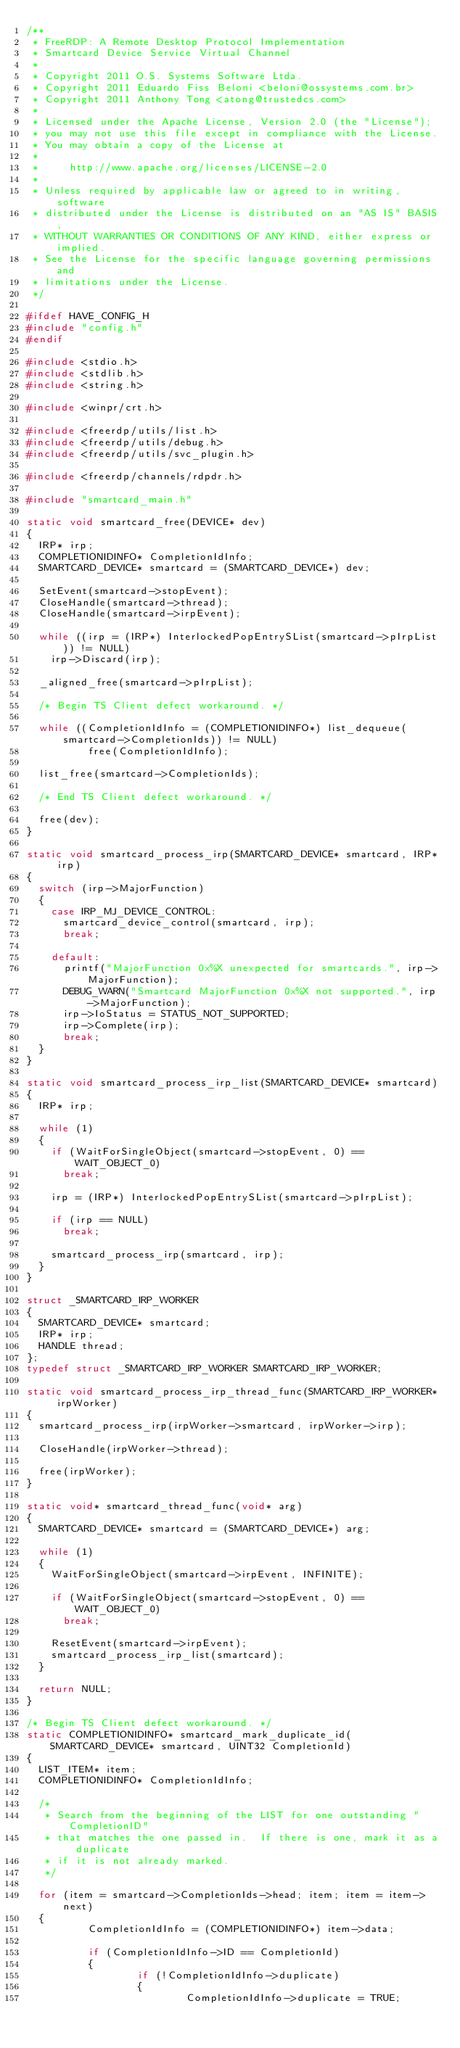<code> <loc_0><loc_0><loc_500><loc_500><_C_>/**
 * FreeRDP: A Remote Desktop Protocol Implementation
 * Smartcard Device Service Virtual Channel
 *
 * Copyright 2011 O.S. Systems Software Ltda.
 * Copyright 2011 Eduardo Fiss Beloni <beloni@ossystems.com.br>
 * Copyright 2011 Anthony Tong <atong@trustedcs.com>
 *
 * Licensed under the Apache License, Version 2.0 (the "License");
 * you may not use this file except in compliance with the License.
 * You may obtain a copy of the License at
 *
 *     http://www.apache.org/licenses/LICENSE-2.0
 *
 * Unless required by applicable law or agreed to in writing, software
 * distributed under the License is distributed on an "AS IS" BASIS,
 * WITHOUT WARRANTIES OR CONDITIONS OF ANY KIND, either express or implied.
 * See the License for the specific language governing permissions and
 * limitations under the License.
 */

#ifdef HAVE_CONFIG_H
#include "config.h"
#endif

#include <stdio.h>
#include <stdlib.h>
#include <string.h>

#include <winpr/crt.h>

#include <freerdp/utils/list.h>
#include <freerdp/utils/debug.h>
#include <freerdp/utils/svc_plugin.h>

#include <freerdp/channels/rdpdr.h>

#include "smartcard_main.h"

static void smartcard_free(DEVICE* dev)
{
	IRP* irp;
	COMPLETIONIDINFO* CompletionIdInfo;
	SMARTCARD_DEVICE* smartcard = (SMARTCARD_DEVICE*) dev;

	SetEvent(smartcard->stopEvent);
	CloseHandle(smartcard->thread);
	CloseHandle(smartcard->irpEvent);

	while ((irp = (IRP*) InterlockedPopEntrySList(smartcard->pIrpList)) != NULL)
		irp->Discard(irp);

	_aligned_free(smartcard->pIrpList);

	/* Begin TS Client defect workaround. */

	while ((CompletionIdInfo = (COMPLETIONIDINFO*) list_dequeue(smartcard->CompletionIds)) != NULL)
	        free(CompletionIdInfo);

	list_free(smartcard->CompletionIds);

	/* End TS Client defect workaround. */

	free(dev);
}

static void smartcard_process_irp(SMARTCARD_DEVICE* smartcard, IRP* irp)
{
	switch (irp->MajorFunction)
	{
		case IRP_MJ_DEVICE_CONTROL:
			smartcard_device_control(smartcard, irp);
			break;

		default:
			printf("MajorFunction 0x%X unexpected for smartcards.", irp->MajorFunction);
			DEBUG_WARN("Smartcard MajorFunction 0x%X not supported.", irp->MajorFunction);
			irp->IoStatus = STATUS_NOT_SUPPORTED;
			irp->Complete(irp);
			break;
	}
}

static void smartcard_process_irp_list(SMARTCARD_DEVICE* smartcard)
{
	IRP* irp;

	while (1)
	{
		if (WaitForSingleObject(smartcard->stopEvent, 0) == WAIT_OBJECT_0)
			break;

		irp = (IRP*) InterlockedPopEntrySList(smartcard->pIrpList);

		if (irp == NULL)
			break;

		smartcard_process_irp(smartcard, irp);
	}
}

struct _SMARTCARD_IRP_WORKER
{
	SMARTCARD_DEVICE* smartcard;
	IRP* irp;
	HANDLE thread;
};
typedef struct _SMARTCARD_IRP_WORKER SMARTCARD_IRP_WORKER;
 
static void smartcard_process_irp_thread_func(SMARTCARD_IRP_WORKER* irpWorker)
{
	smartcard_process_irp(irpWorker->smartcard, irpWorker->irp);

	CloseHandle(irpWorker->thread);

	free(irpWorker);
}

static void* smartcard_thread_func(void* arg)
{
	SMARTCARD_DEVICE* smartcard = (SMARTCARD_DEVICE*) arg;

	while (1)
	{
		WaitForSingleObject(smartcard->irpEvent, INFINITE);

		if (WaitForSingleObject(smartcard->stopEvent, 0) == WAIT_OBJECT_0)
			break;

		ResetEvent(smartcard->irpEvent);
		smartcard_process_irp_list(smartcard);
	}

	return NULL;
}

/* Begin TS Client defect workaround. */
static COMPLETIONIDINFO* smartcard_mark_duplicate_id(SMARTCARD_DEVICE* smartcard, UINT32 CompletionId)
{
	LIST_ITEM* item;
	COMPLETIONIDINFO* CompletionIdInfo;

	/*
	 * Search from the beginning of the LIST for one outstanding "CompletionID"
	 * that matches the one passed in.  If there is one, mark it as a duplicate
	 * if it is not already marked.
	 */

	for (item = smartcard->CompletionIds->head; item; item = item->next)
	{
	        CompletionIdInfo = (COMPLETIONIDINFO*) item->data;

	        if (CompletionIdInfo->ID == CompletionId)
	        {
	                if (!CompletionIdInfo->duplicate)
	                {
	                        CompletionIdInfo->duplicate = TRUE;</code> 